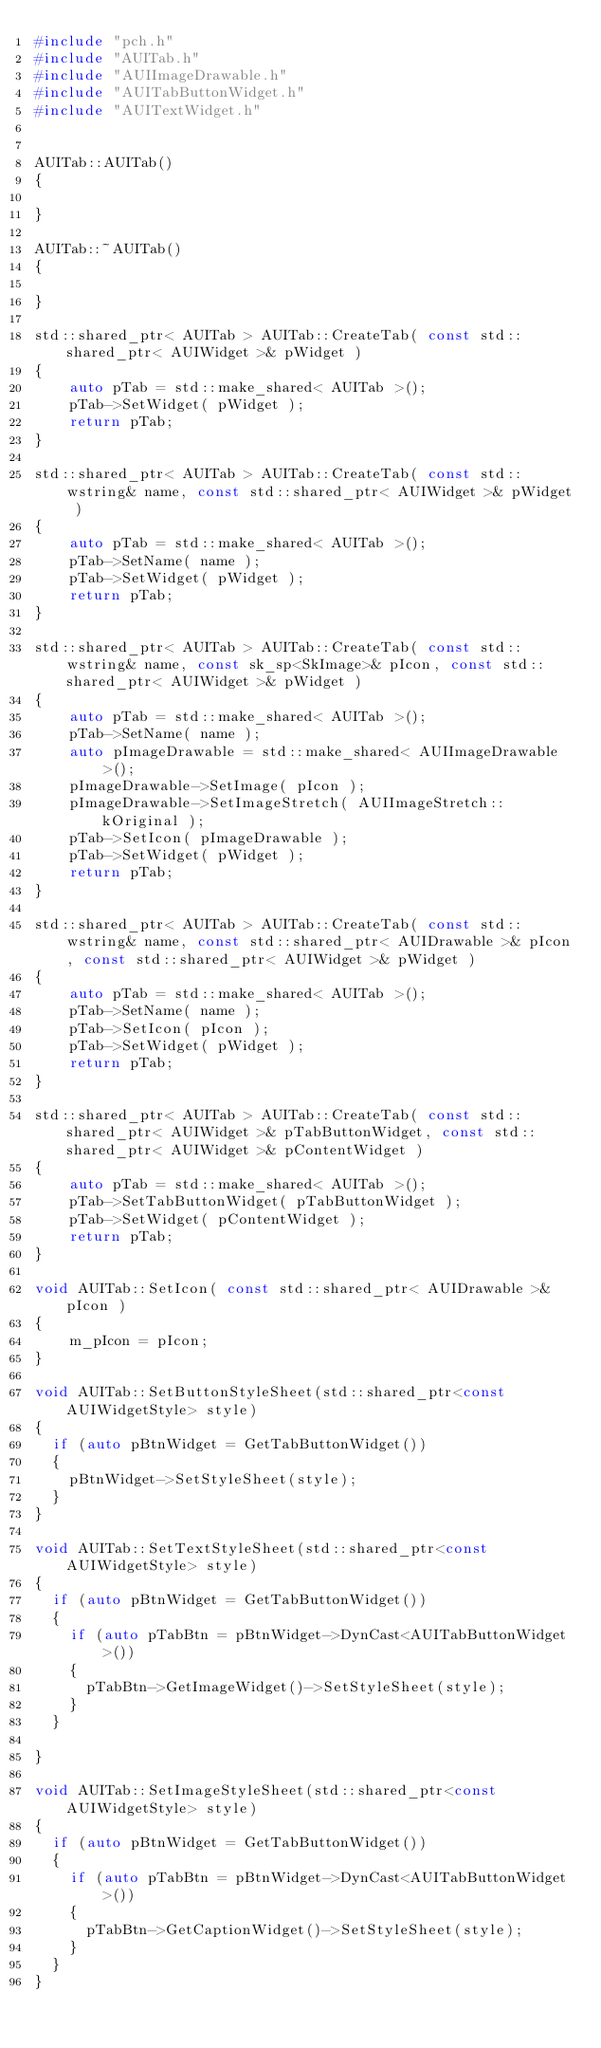Convert code to text. <code><loc_0><loc_0><loc_500><loc_500><_C++_>#include "pch.h"
#include "AUITab.h"
#include "AUIImageDrawable.h"
#include "AUITabButtonWidget.h"
#include "AUITextWidget.h"


AUITab::AUITab()
{
    
}

AUITab::~AUITab()
{

}

std::shared_ptr< AUITab > AUITab::CreateTab( const std::shared_ptr< AUIWidget >& pWidget )
{
    auto pTab = std::make_shared< AUITab >();
    pTab->SetWidget( pWidget );
    return pTab;
}

std::shared_ptr< AUITab > AUITab::CreateTab( const std::wstring& name, const std::shared_ptr< AUIWidget >& pWidget )
{
    auto pTab = std::make_shared< AUITab >();
    pTab->SetName( name );
    pTab->SetWidget( pWidget );
    return pTab;
}

std::shared_ptr< AUITab > AUITab::CreateTab( const std::wstring& name, const sk_sp<SkImage>& pIcon, const std::shared_ptr< AUIWidget >& pWidget )
{
    auto pTab = std::make_shared< AUITab >();
    pTab->SetName( name );
    auto pImageDrawable = std::make_shared< AUIImageDrawable >();
    pImageDrawable->SetImage( pIcon );
    pImageDrawable->SetImageStretch( AUIImageStretch::kOriginal );
    pTab->SetIcon( pImageDrawable );
    pTab->SetWidget( pWidget );
    return pTab;
}

std::shared_ptr< AUITab > AUITab::CreateTab( const std::wstring& name, const std::shared_ptr< AUIDrawable >& pIcon, const std::shared_ptr< AUIWidget >& pWidget )
{
    auto pTab = std::make_shared< AUITab >();
    pTab->SetName( name );
    pTab->SetIcon( pIcon );
    pTab->SetWidget( pWidget );
    return pTab;
}

std::shared_ptr< AUITab > AUITab::CreateTab( const std::shared_ptr< AUIWidget >& pTabButtonWidget, const std::shared_ptr< AUIWidget >& pContentWidget )
{
    auto pTab = std::make_shared< AUITab >();
    pTab->SetTabButtonWidget( pTabButtonWidget );
    pTab->SetWidget( pContentWidget );
    return pTab;
}

void AUITab::SetIcon( const std::shared_ptr< AUIDrawable >& pIcon )
{
    m_pIcon = pIcon;
}

void AUITab::SetButtonStyleSheet(std::shared_ptr<const AUIWidgetStyle> style)
{
	if (auto pBtnWidget = GetTabButtonWidget())
	{
		pBtnWidget->SetStyleSheet(style);
	}
}

void AUITab::SetTextStyleSheet(std::shared_ptr<const AUIWidgetStyle> style)
{
	if (auto pBtnWidget = GetTabButtonWidget())
	{
		if (auto pTabBtn = pBtnWidget->DynCast<AUITabButtonWidget>())
		{
			pTabBtn->GetImageWidget()->SetStyleSheet(style);
		}
	}

}

void AUITab::SetImageStyleSheet(std::shared_ptr<const AUIWidgetStyle> style)
{
	if (auto pBtnWidget = GetTabButtonWidget())
	{
		if (auto pTabBtn = pBtnWidget->DynCast<AUITabButtonWidget>())
		{
			pTabBtn->GetCaptionWidget()->SetStyleSheet(style);
		}
	}
}
</code> 